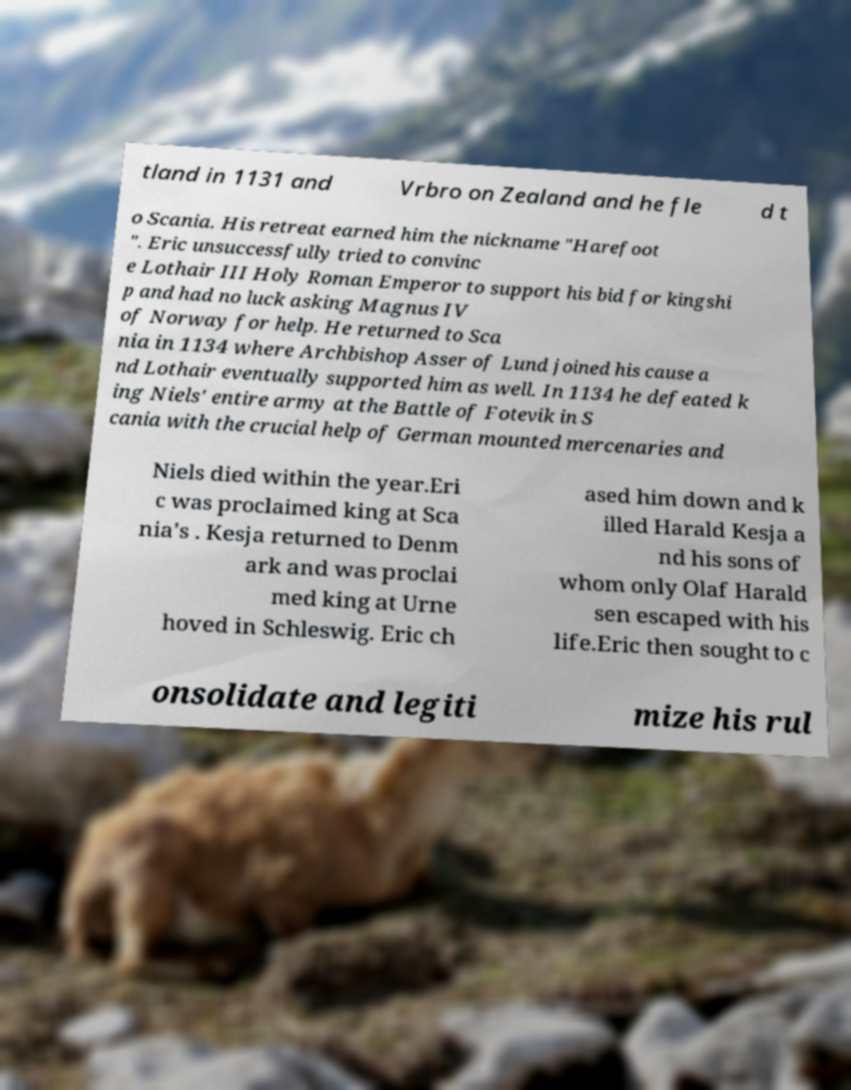There's text embedded in this image that I need extracted. Can you transcribe it verbatim? tland in 1131 and Vrbro on Zealand and he fle d t o Scania. His retreat earned him the nickname "Harefoot ". Eric unsuccessfully tried to convinc e Lothair III Holy Roman Emperor to support his bid for kingshi p and had no luck asking Magnus IV of Norway for help. He returned to Sca nia in 1134 where Archbishop Asser of Lund joined his cause a nd Lothair eventually supported him as well. In 1134 he defeated k ing Niels' entire army at the Battle of Fotevik in S cania with the crucial help of German mounted mercenaries and Niels died within the year.Eri c was proclaimed king at Sca nia's . Kesja returned to Denm ark and was proclai med king at Urne hoved in Schleswig. Eric ch ased him down and k illed Harald Kesja a nd his sons of whom only Olaf Harald sen escaped with his life.Eric then sought to c onsolidate and legiti mize his rul 